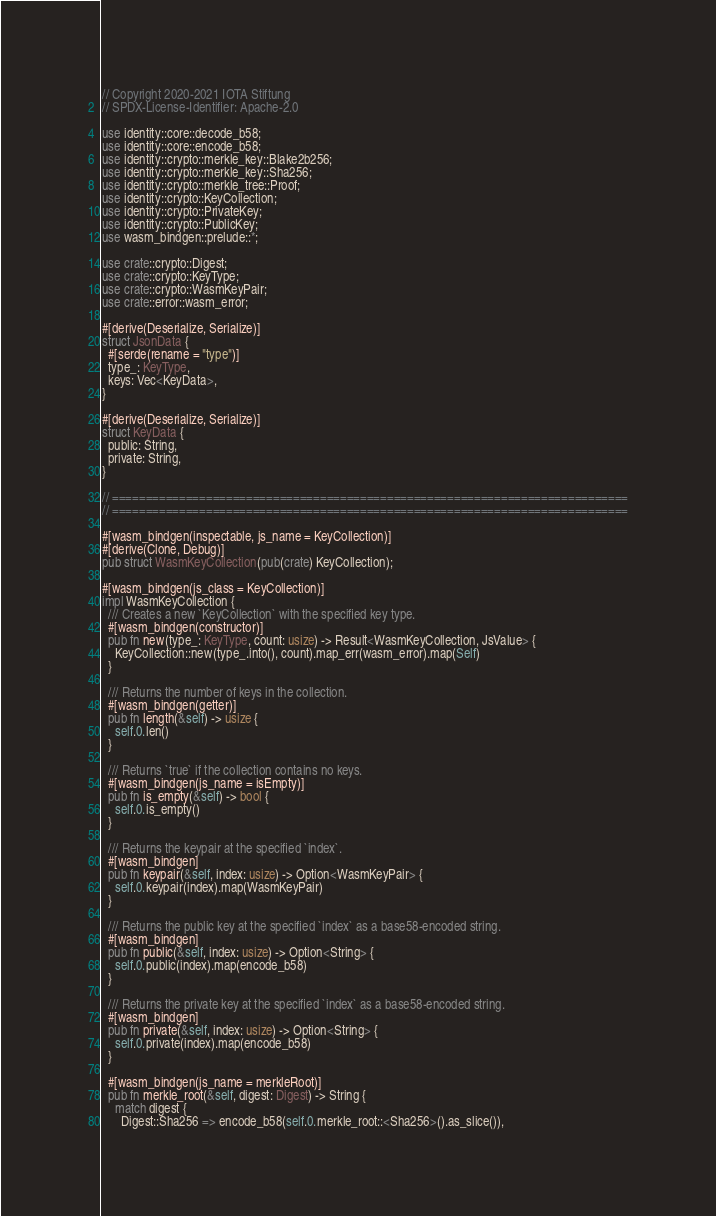<code> <loc_0><loc_0><loc_500><loc_500><_Rust_>// Copyright 2020-2021 IOTA Stiftung
// SPDX-License-Identifier: Apache-2.0

use identity::core::decode_b58;
use identity::core::encode_b58;
use identity::crypto::merkle_key::Blake2b256;
use identity::crypto::merkle_key::Sha256;
use identity::crypto::merkle_tree::Proof;
use identity::crypto::KeyCollection;
use identity::crypto::PrivateKey;
use identity::crypto::PublicKey;
use wasm_bindgen::prelude::*;

use crate::crypto::Digest;
use crate::crypto::KeyType;
use crate::crypto::WasmKeyPair;
use crate::error::wasm_error;

#[derive(Deserialize, Serialize)]
struct JsonData {
  #[serde(rename = "type")]
  type_: KeyType,
  keys: Vec<KeyData>,
}

#[derive(Deserialize, Serialize)]
struct KeyData {
  public: String,
  private: String,
}

// =============================================================================
// =============================================================================

#[wasm_bindgen(inspectable, js_name = KeyCollection)]
#[derive(Clone, Debug)]
pub struct WasmKeyCollection(pub(crate) KeyCollection);

#[wasm_bindgen(js_class = KeyCollection)]
impl WasmKeyCollection {
  /// Creates a new `KeyCollection` with the specified key type.
  #[wasm_bindgen(constructor)]
  pub fn new(type_: KeyType, count: usize) -> Result<WasmKeyCollection, JsValue> {
    KeyCollection::new(type_.into(), count).map_err(wasm_error).map(Self)
  }

  /// Returns the number of keys in the collection.
  #[wasm_bindgen(getter)]
  pub fn length(&self) -> usize {
    self.0.len()
  }

  /// Returns `true` if the collection contains no keys.
  #[wasm_bindgen(js_name = isEmpty)]
  pub fn is_empty(&self) -> bool {
    self.0.is_empty()
  }

  /// Returns the keypair at the specified `index`.
  #[wasm_bindgen]
  pub fn keypair(&self, index: usize) -> Option<WasmKeyPair> {
    self.0.keypair(index).map(WasmKeyPair)
  }

  /// Returns the public key at the specified `index` as a base58-encoded string.
  #[wasm_bindgen]
  pub fn public(&self, index: usize) -> Option<String> {
    self.0.public(index).map(encode_b58)
  }

  /// Returns the private key at the specified `index` as a base58-encoded string.
  #[wasm_bindgen]
  pub fn private(&self, index: usize) -> Option<String> {
    self.0.private(index).map(encode_b58)
  }

  #[wasm_bindgen(js_name = merkleRoot)]
  pub fn merkle_root(&self, digest: Digest) -> String {
    match digest {
      Digest::Sha256 => encode_b58(self.0.merkle_root::<Sha256>().as_slice()),</code> 